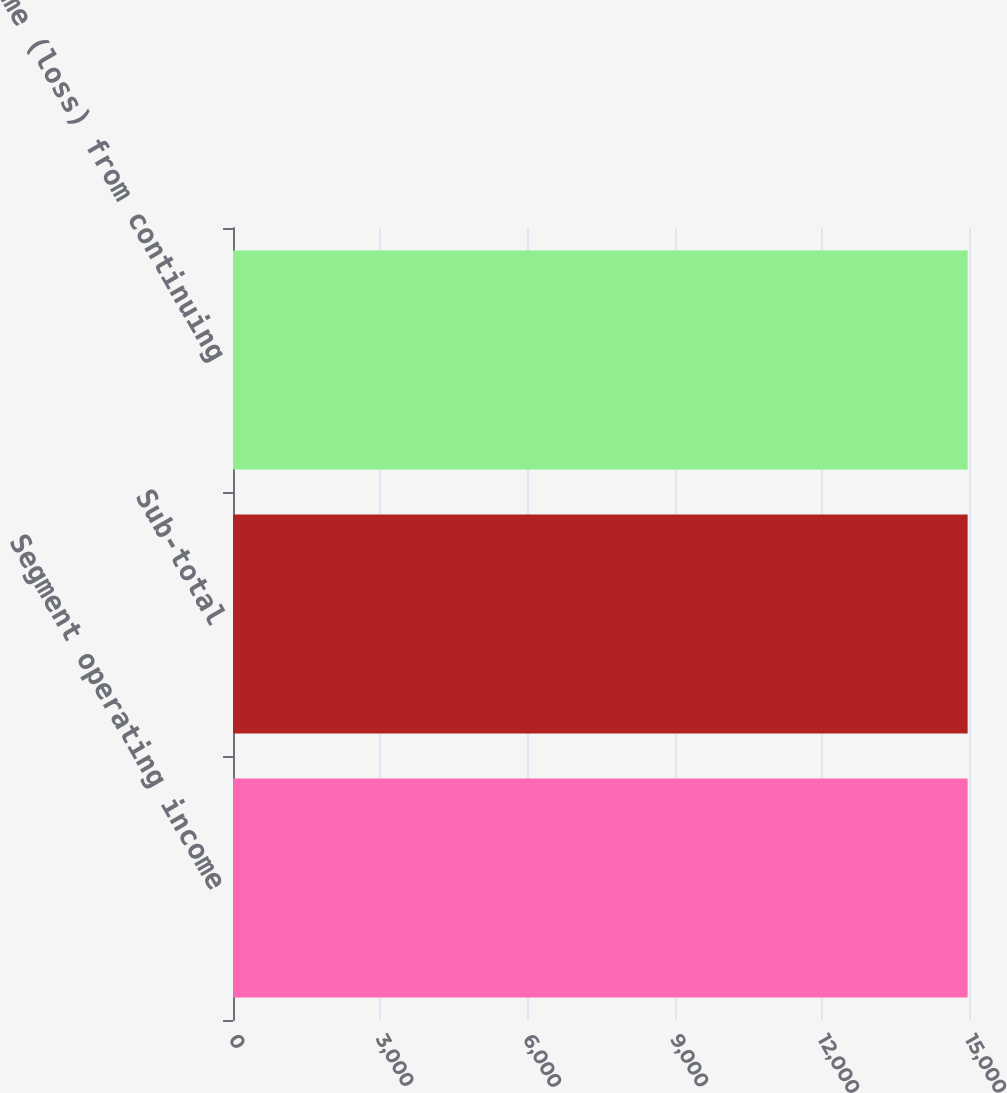<chart> <loc_0><loc_0><loc_500><loc_500><bar_chart><fcel>Segment operating income<fcel>Sub-total<fcel>Income (loss) from continuing<nl><fcel>14972<fcel>14972.1<fcel>14972.2<nl></chart> 